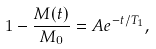<formula> <loc_0><loc_0><loc_500><loc_500>1 - \frac { M ( t ) } { M _ { 0 } } = A e ^ { - t / T _ { 1 } } ,</formula> 